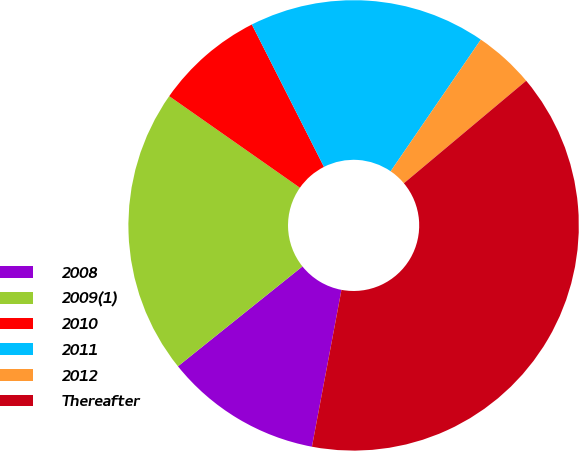Convert chart to OTSL. <chart><loc_0><loc_0><loc_500><loc_500><pie_chart><fcel>2008<fcel>2009(1)<fcel>2010<fcel>2011<fcel>2012<fcel>Thereafter<nl><fcel>11.28%<fcel>20.49%<fcel>7.81%<fcel>17.02%<fcel>4.34%<fcel>39.07%<nl></chart> 